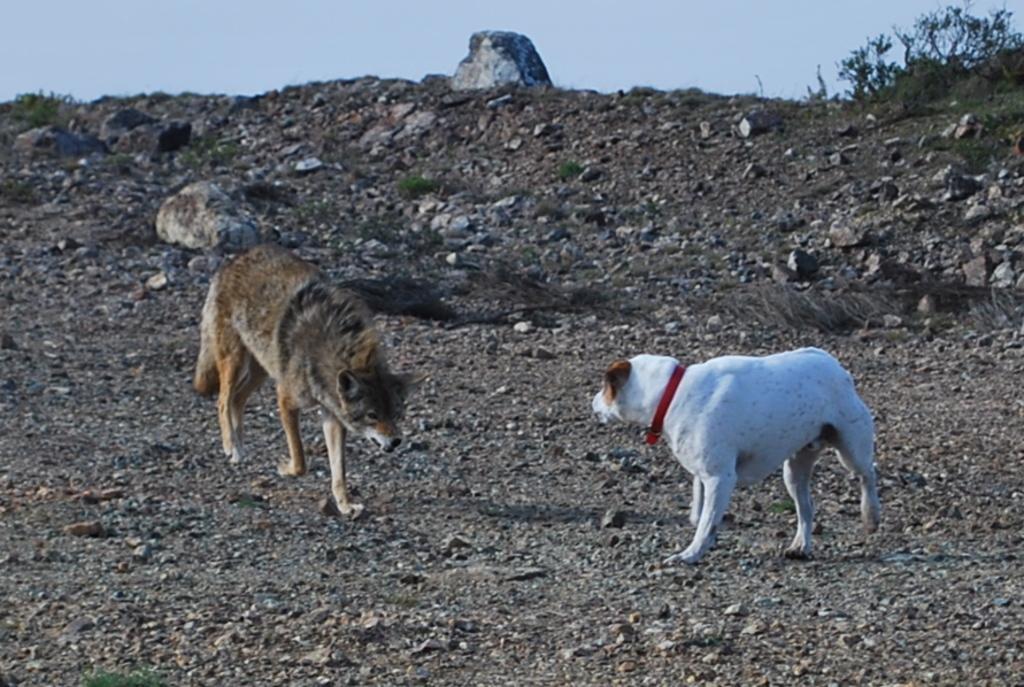In one or two sentences, can you explain what this image depicts? In this image in the center there are two dogs. At the bottom there are some grass and sand, at the top of the image there is sky. 